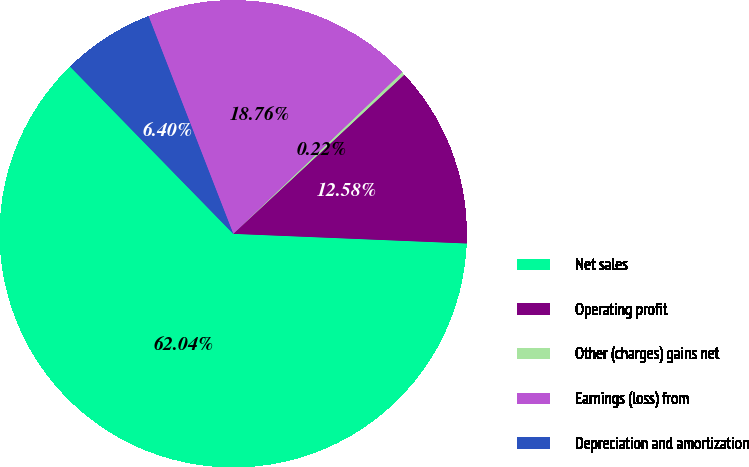Convert chart. <chart><loc_0><loc_0><loc_500><loc_500><pie_chart><fcel>Net sales<fcel>Operating profit<fcel>Other (charges) gains net<fcel>Earnings (loss) from<fcel>Depreciation and amortization<nl><fcel>62.03%<fcel>12.58%<fcel>0.22%<fcel>18.76%<fcel>6.4%<nl></chart> 